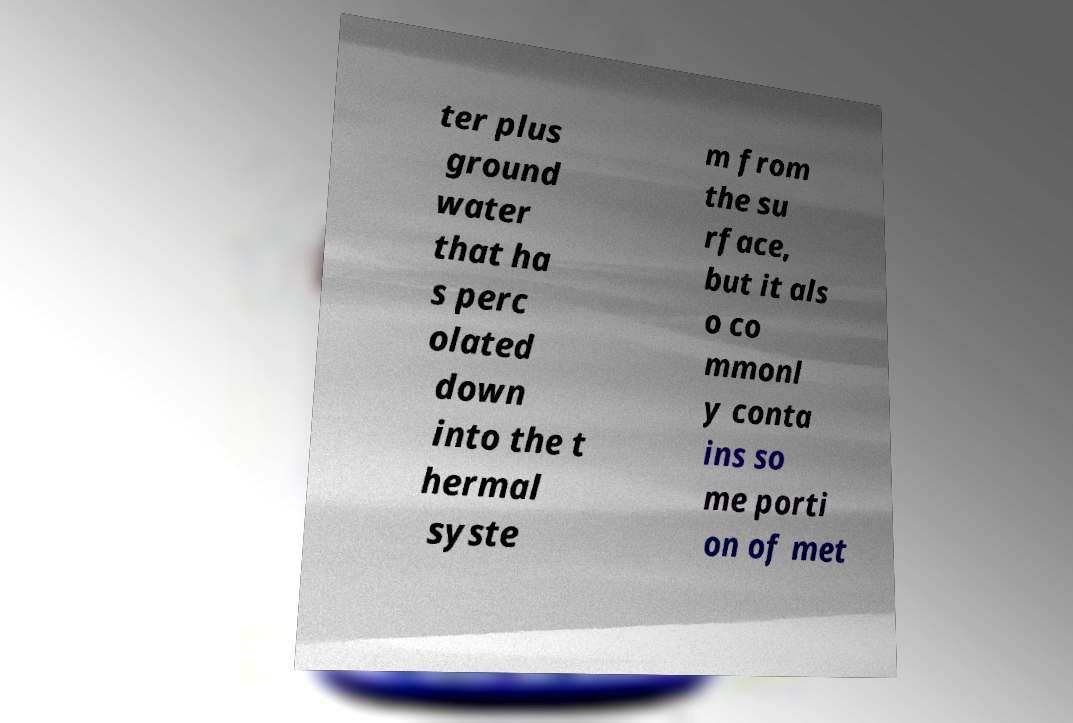Please read and relay the text visible in this image. What does it say? ter plus ground water that ha s perc olated down into the t hermal syste m from the su rface, but it als o co mmonl y conta ins so me porti on of met 